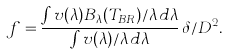Convert formula to latex. <formula><loc_0><loc_0><loc_500><loc_500>f = \frac { \int v ( \lambda ) B _ { \lambda } ( T _ { B R } ) / \lambda \, d \lambda } { \int v ( \lambda ) / \lambda \, d \lambda } \, \delta / D ^ { 2 } .</formula> 